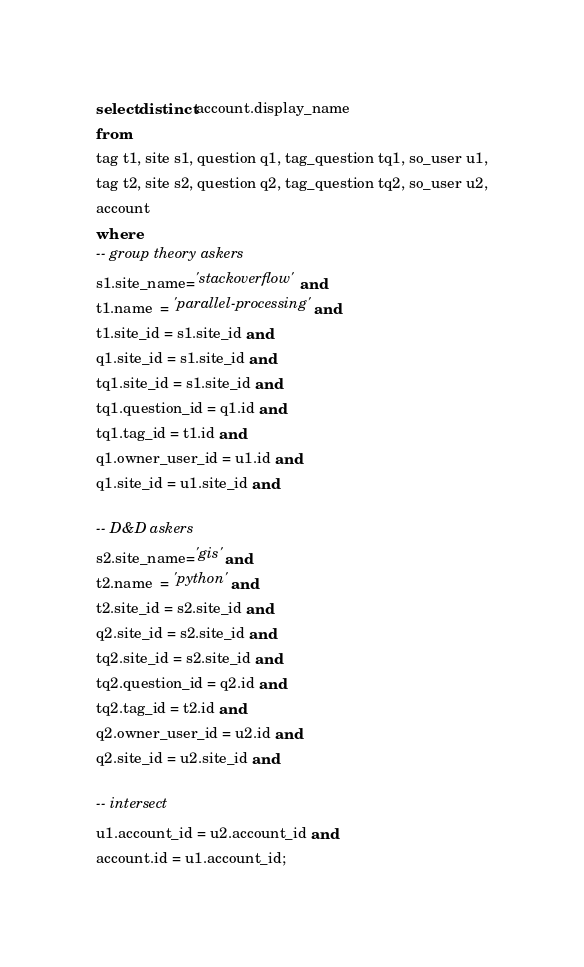Convert code to text. <code><loc_0><loc_0><loc_500><loc_500><_SQL_>select distinct account.display_name
from
tag t1, site s1, question q1, tag_question tq1, so_user u1,
tag t2, site s2, question q2, tag_question tq2, so_user u2,
account
where
-- group theory askers
s1.site_name='stackoverflow' and
t1.name  = 'parallel-processing' and
t1.site_id = s1.site_id and
q1.site_id = s1.site_id and
tq1.site_id = s1.site_id and
tq1.question_id = q1.id and
tq1.tag_id = t1.id and
q1.owner_user_id = u1.id and
q1.site_id = u1.site_id and

-- D&D askers
s2.site_name='gis' and
t2.name  = 'python' and
t2.site_id = s2.site_id and
q2.site_id = s2.site_id and
tq2.site_id = s2.site_id and
tq2.question_id = q2.id and
tq2.tag_id = t2.id and
q2.owner_user_id = u2.id and
q2.site_id = u2.site_id and

-- intersect
u1.account_id = u2.account_id and
account.id = u1.account_id;

</code> 